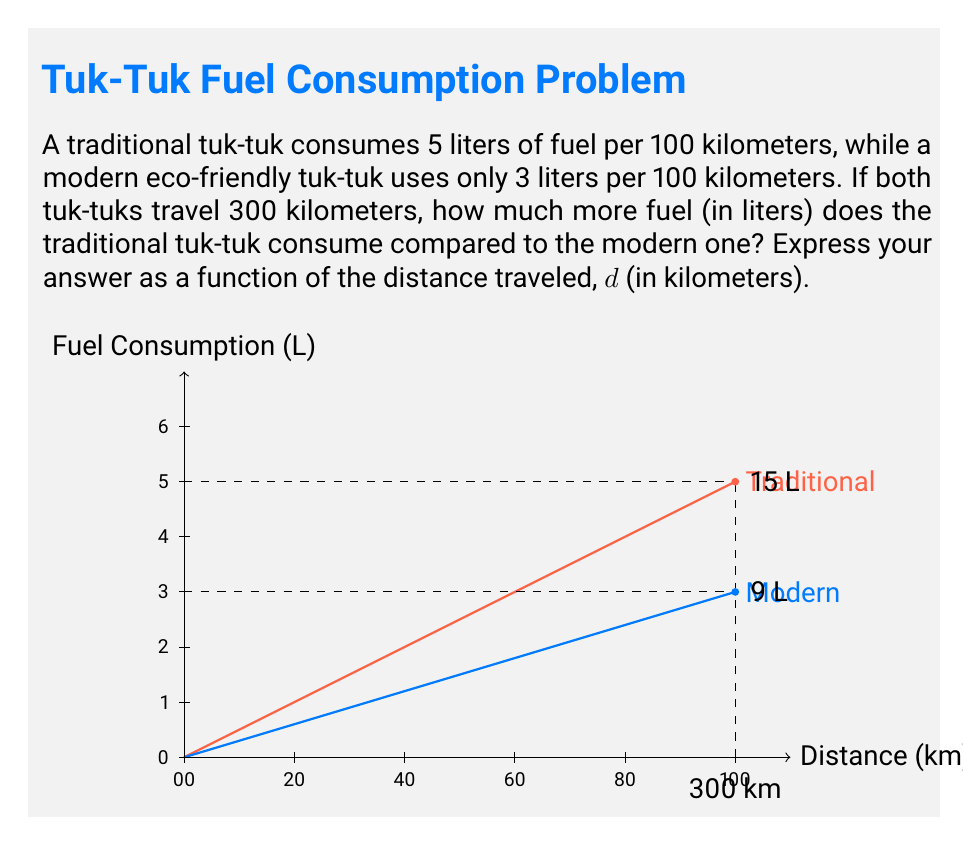Provide a solution to this math problem. Let's approach this step-by-step:

1) First, let's define our functions for fuel consumption:
   
   For traditional tuk-tuk: $f_t(d) = \frac{5d}{100}$
   For modern tuk-tuk: $f_m(d) = \frac{3d}{100}$

   Where $d$ is the distance traveled in kilometers.

2) The difference in fuel consumption is:
   
   $\Delta f(d) = f_t(d) - f_m(d) = \frac{5d}{100} - \frac{3d}{100}$

3) Simplify:
   
   $\Delta f(d) = \frac{5d-3d}{100} = \frac{2d}{100} = \frac{d}{50}$

4) This function $\Delta f(d) = \frac{d}{50}$ represents the additional fuel consumed by the traditional tuk-tuk compared to the modern one for any given distance $d$.

5) For the specific case of 300 km:
   
   $\Delta f(300) = \frac{300}{50} = 6$ liters

Thus, for a 300 km trip, the traditional tuk-tuk consumes 6 liters more fuel than the modern one.
Answer: $\Delta f(d) = \frac{d}{50}$ liters 